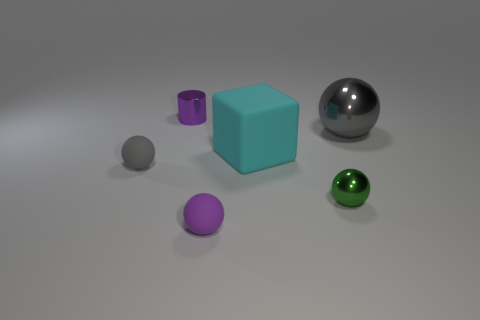Add 2 gray metallic balls. How many objects exist? 8 Subtract all cylinders. How many objects are left? 5 Subtract all gray metal spheres. Subtract all large cyan blocks. How many objects are left? 4 Add 2 big rubber objects. How many big rubber objects are left? 3 Add 5 cyan shiny cylinders. How many cyan shiny cylinders exist? 5 Subtract 0 cyan balls. How many objects are left? 6 